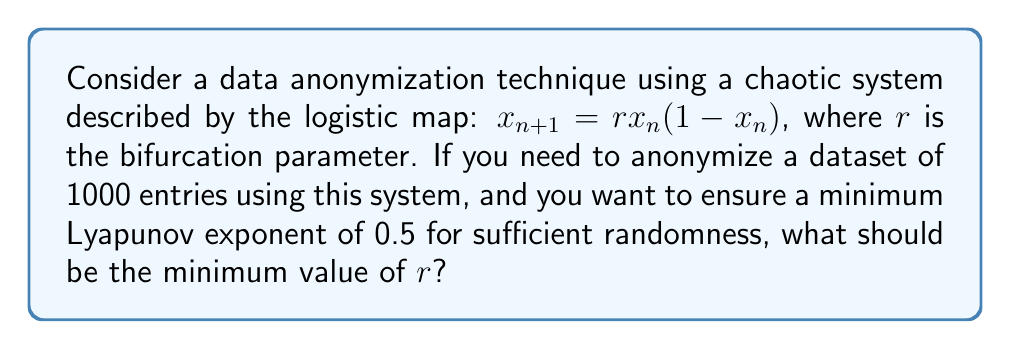Solve this math problem. To solve this problem, we need to follow these steps:

1) The Lyapunov exponent ($\lambda$) for the logistic map is given by:

   $$\lambda = \lim_{n \to \infty} \frac{1}{n} \sum_{i=0}^{n-1} \ln |r(1-2x_i)|$$

2) For the logistic map, the Lyapunov exponent becomes positive (indicating chaos) when $r > 3.57$.

3) To find the specific $r$ value for a given Lyapunov exponent, we can use the approximation:

   $$\lambda \approx \ln(r) - \frac{2}{r}$$

4) We want $\lambda = 0.5$, so we substitute this into our equation:

   $$0.5 = \ln(r) - \frac{2}{r}$$

5) This equation can't be solved analytically, so we need to use numerical methods. Using a numerical solver or graphing calculator, we find:

   $$r \approx 3.86$$

6) Therefore, to ensure a Lyapunov exponent of at least 0.5, we need $r$ to be at least 3.86.
Answer: 3.86 